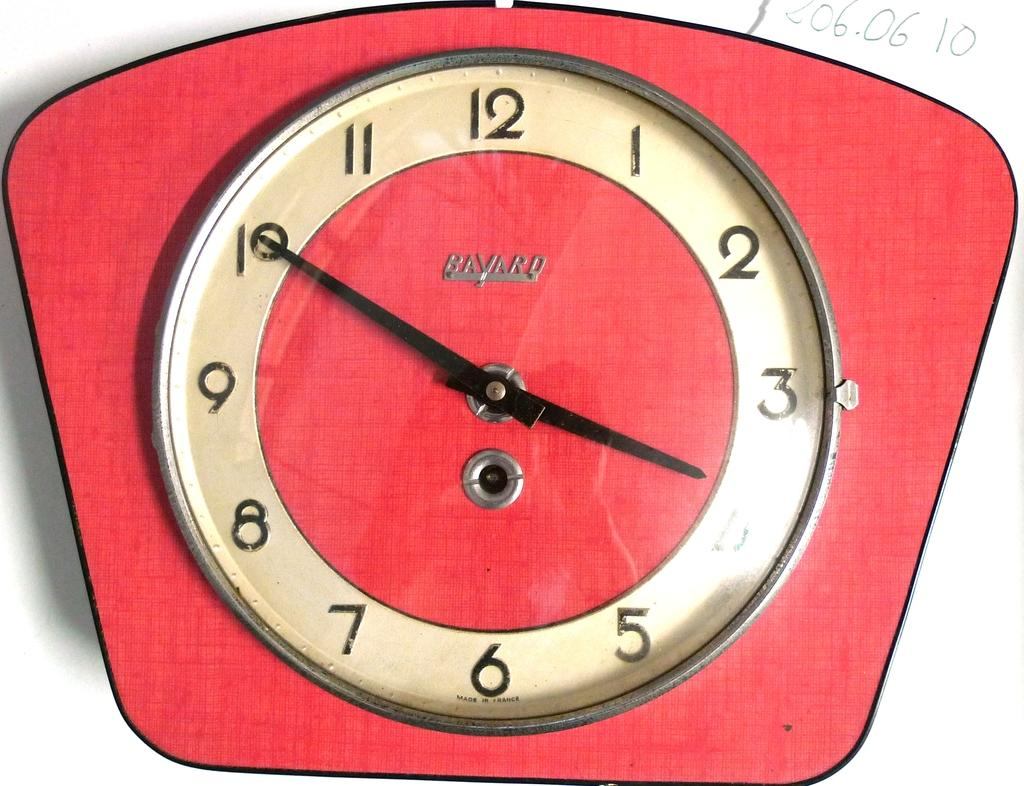<image>
Describe the image concisely. a clock that has the number 3 on it 